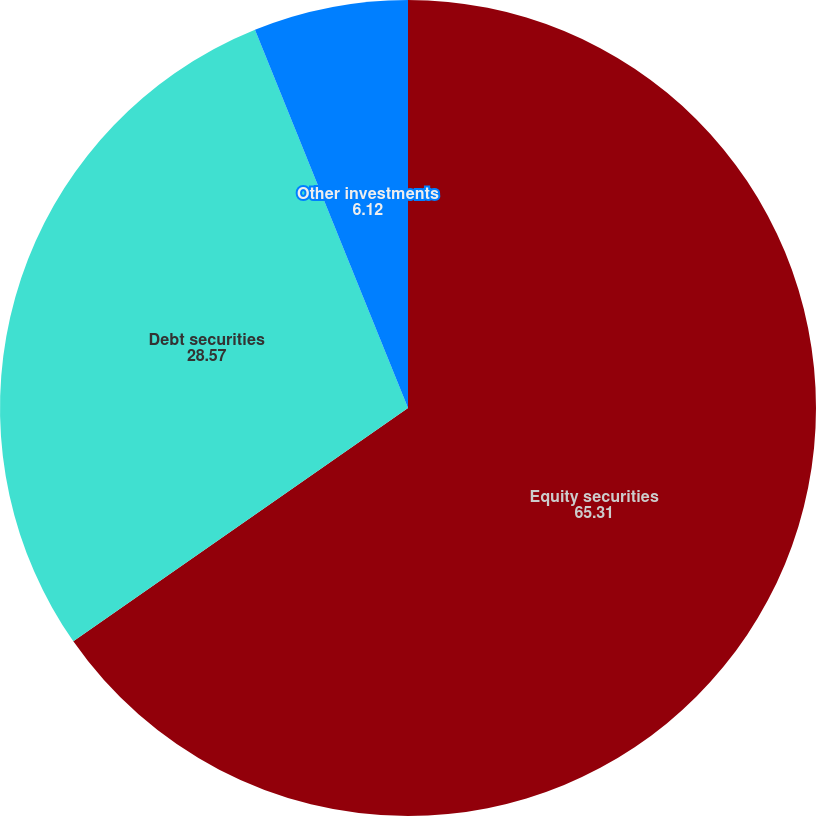<chart> <loc_0><loc_0><loc_500><loc_500><pie_chart><fcel>Equity securities<fcel>Debt securities<fcel>Other investments<nl><fcel>65.31%<fcel>28.57%<fcel>6.12%<nl></chart> 